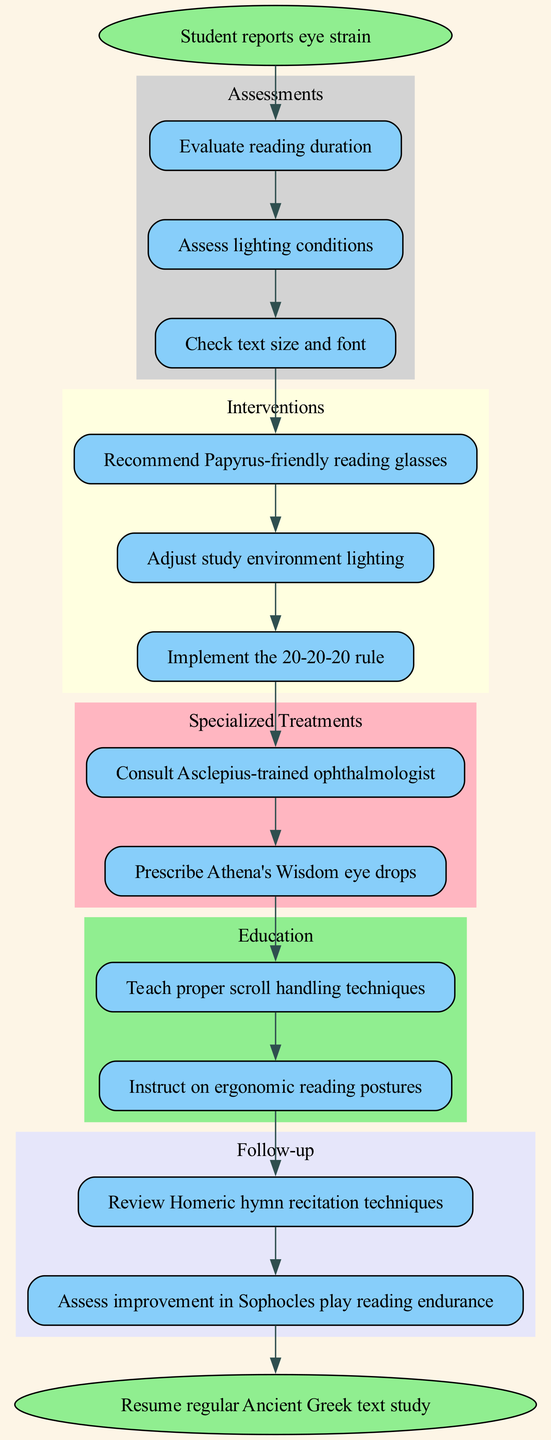What is the starting point of the clinical pathway? The diagram indicates that the starting point is labeled "Student reports eye strain." This can be found at the very top of the diagram as the initial node.
Answer: Student reports eye strain How many assessments are listed in the diagram? There are three assessments present, which are specified in the 'Assessments' cluster. This can be counted directly from the subgraph that lists the assessments.
Answer: 3 What intervention comes after assessing the lighting conditions? Following the 'Assessments' section, the diagram indicates that the first intervention after all assessments is to "Recommend Papyrus-friendly reading glasses." This connects directly to the last assessment node.
Answer: Recommend Papyrus-friendly reading glasses What is the relationship between interventions and specialized treatments? The diagram shows a direct connection from the last intervention to the first specialized treatment. This indicates that specialized treatments come after all the interventions have been completed.
Answer: Specialized treatments come after interventions How many follow-up evaluations are there? The diagram reveals that there are two follow-up evaluations listed in the 'Follow-up' cluster. This can be counted within the follow-up section of the diagram.
Answer: 2 What is the final step of the clinical pathway? The final step of the pathway is labeled "Resume regular Ancient Greek text study," which is the endpoint of the flow. This can be seen at the bottom of the diagram as the conclusion.
Answer: Resume regular Ancient Greek text study Which specialized treatment has been mentioned in the diagram? The specialized treatment listed is "Prescribe Athena's Wisdom eye drops," found within the 'Specialized Treatments' section. This is a specific treatment noted in the diagram.
Answer: Prescribe Athena's Wisdom eye drops What educational content is provided in the pathway? The educational content includes "Teach proper scroll handling techniques" and "Instruct on ergonomic reading postures," both of which are part of the 'Education' cluster. These can be found listed under the corresponding section.
Answer: Teach proper scroll handling techniques; Instruct on ergonomic reading postures What do you do before reviewing follow-up techniques? Before moving on to the follow-up evaluations, you must complete the education interventions. This is indicated by the direct connection in the diagram from the last educational intervention to the first follow-up evaluation.
Answer: Complete education interventions 